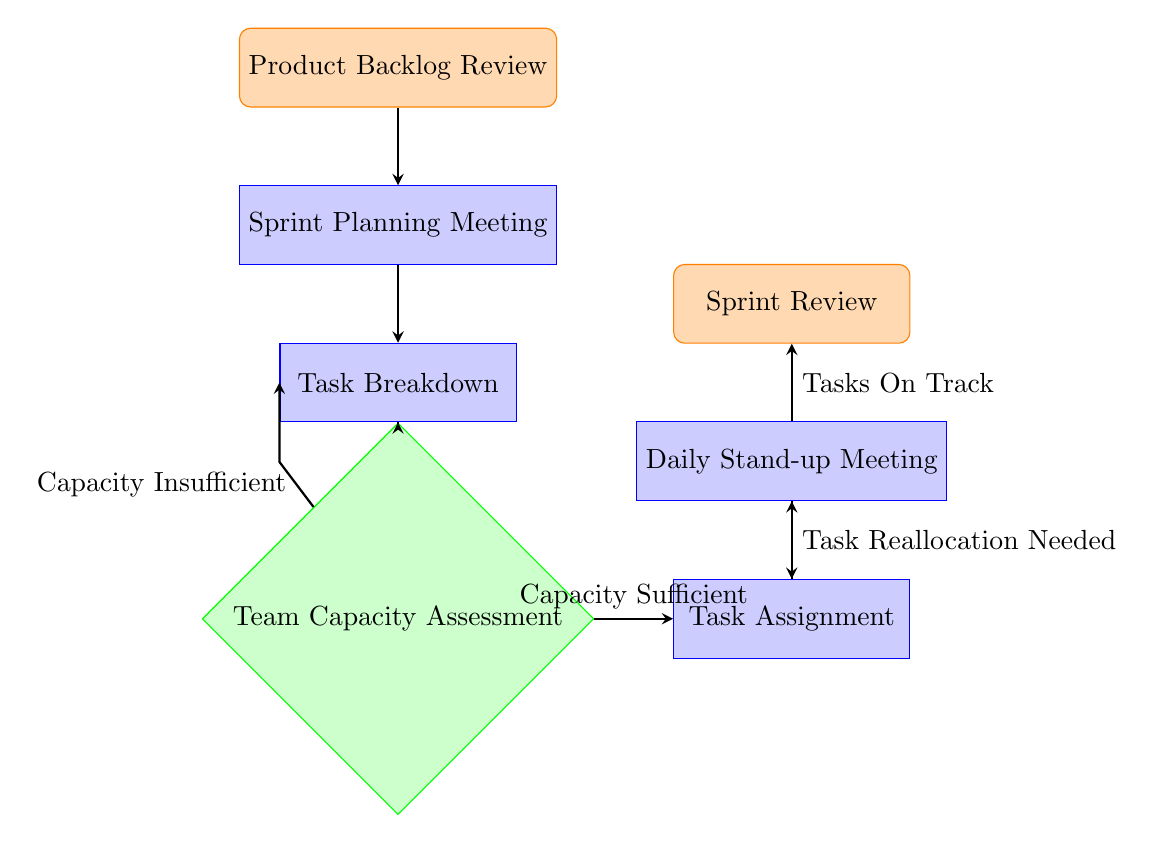What is the first node in the process? The first node, labeled as "Product Backlog Review," is the starting point of the task allocation process in Scrum. It represents the initial step where tasks are reviewed and prioritized before moving on to subsequent nodes.
Answer: Product Backlog Review How many total nodes are there in the diagram? By counting each unique node listed in the diagram data, we identify a total of 7 nodes, including the starting node and the ending node.
Answer: 7 What is the label of the node following Sprint Planning Meeting? The node that directly follows "Sprint Planning Meeting" is "Task Breakdown," as indicated by the flow from planning to breakdown.
Answer: Task Breakdown What condition leads to the Task Assignment node from Team Capacity Assessment? The condition leading from "Team Capacity Assessment" to "Task Assignment" is when the team’s capacity is assessed to be "Capacity Sufficient," indicating that there are enough resources available.
Answer: Capacity Sufficient If the team’s capacity is insufficient, which node do they return to? When the capacity is insufficient, the flow directs teams back to "Task Breakdown," allowing for a reassessment of the tasks to make them manageable based on available capacity.
Answer: Task Breakdown What is the last node in the process? The last node in the flow chart is "Sprint Review," which indicates the conclusion of the task allocation process where completed tasks are reviewed and feedback is gathered.
Answer: Sprint Review During what meeting are tasks reviewed and potentially reallocated? The tasks are reviewed and potentially reallocated during the "Daily Stand-up Meeting." This meeting allows the team to assess progress and make necessary adjustments to task allocation.
Answer: Daily Stand-up Meeting How many edges connect the nodes in this flow chart? The total number of edges can be determined by counting the connections between the nodes. In this diagram, there are 8 edges representing the flow and decision paths connecting the various steps.
Answer: 8 What happens if tasks are on track during the Daily Stand-up Meeting? If tasks are on track during the "Daily Stand-up Meeting," the flow moves forward to the "Sprint Review," indicating that the team can proceed to evaluate the completed tasks.
Answer: Sprint Review 